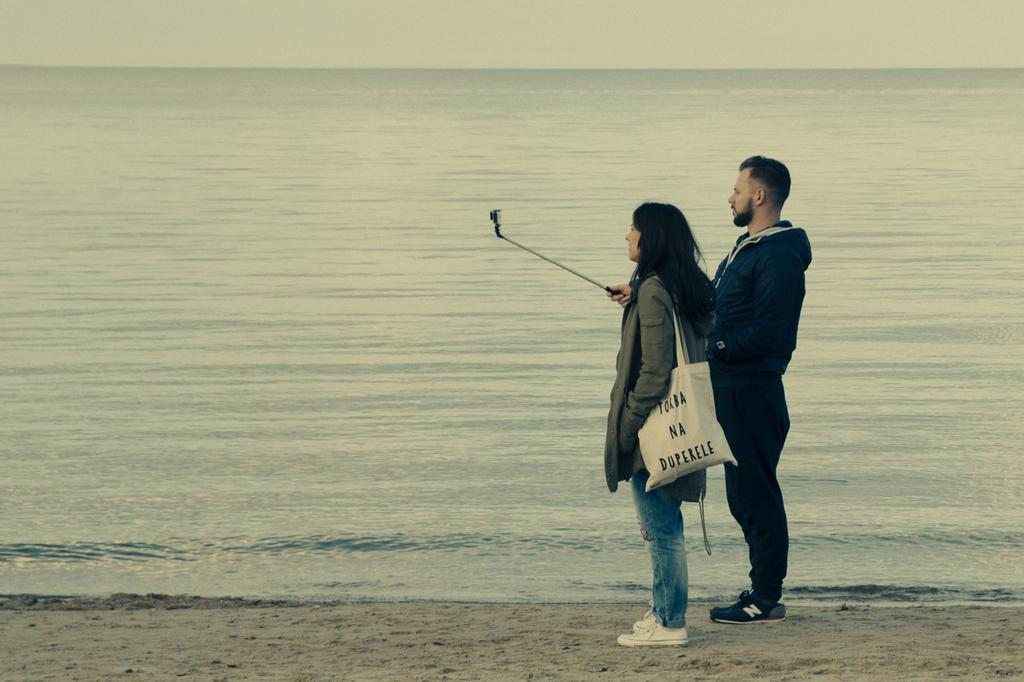What is the man in the image holding? The man is holding a selfie stick in the image. What is the woman in the image carrying? The woman is carrying a bag in the image. What type of surface are the man and woman standing on? They are standing on sand in the image. What can be seen in the background of the image? Water and the sky are visible in the background of the image. What type of sock is the man wearing in the image? There is no information about the man's socks in the image, so we cannot determine if he is wearing a sock or what type it might be. 